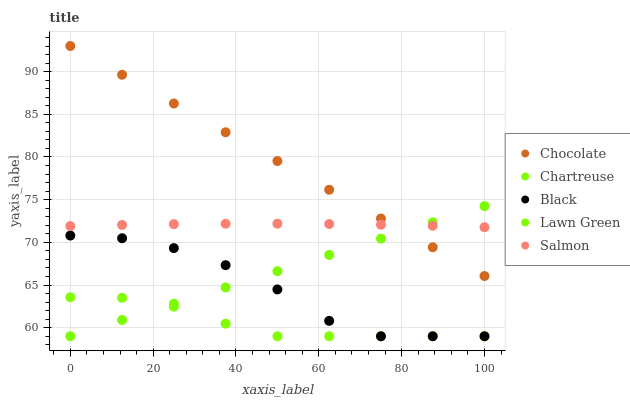Does Chartreuse have the minimum area under the curve?
Answer yes or no. Yes. Does Chocolate have the maximum area under the curve?
Answer yes or no. Yes. Does Salmon have the minimum area under the curve?
Answer yes or no. No. Does Salmon have the maximum area under the curve?
Answer yes or no. No. Is Chocolate the smoothest?
Answer yes or no. Yes. Is Black the roughest?
Answer yes or no. Yes. Is Chartreuse the smoothest?
Answer yes or no. No. Is Chartreuse the roughest?
Answer yes or no. No. Does Lawn Green have the lowest value?
Answer yes or no. Yes. Does Salmon have the lowest value?
Answer yes or no. No. Does Chocolate have the highest value?
Answer yes or no. Yes. Does Salmon have the highest value?
Answer yes or no. No. Is Black less than Chocolate?
Answer yes or no. Yes. Is Salmon greater than Chartreuse?
Answer yes or no. Yes. Does Salmon intersect Lawn Green?
Answer yes or no. Yes. Is Salmon less than Lawn Green?
Answer yes or no. No. Is Salmon greater than Lawn Green?
Answer yes or no. No. Does Black intersect Chocolate?
Answer yes or no. No. 